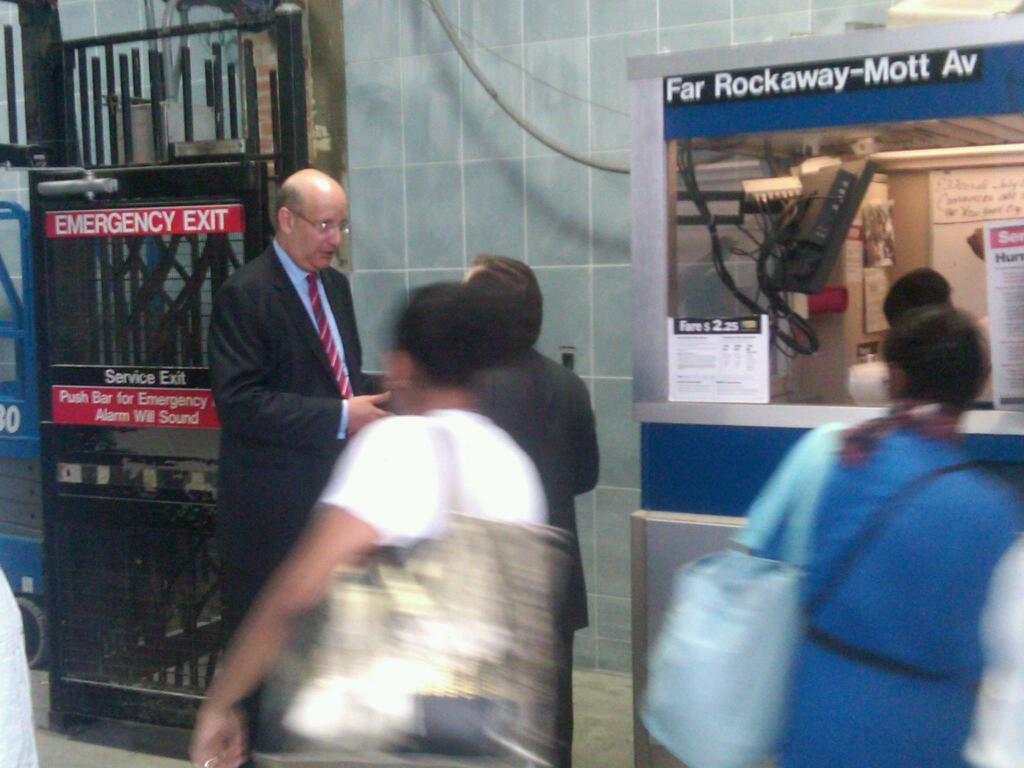What can be seen on the path in the image? There are people on a path in the image. What is located on the left side of the image? There is a gate on the left side of the image. What electronic device is present in the image? There is a television in the image. How many people are visible in the image? There is at least one person in the image. What type of storage is shown in the image? There are boards on a shelf in the image. Can you describe the bee buzzing around the television in the image? There is no bee present in the image; it only features people, a gate, a television, a person, and boards on a shelf. What type of pest is crawling on the boards in the image? There are no pests present in the image; it only features people, a gate, a television, a person, and boards on a shelf. 